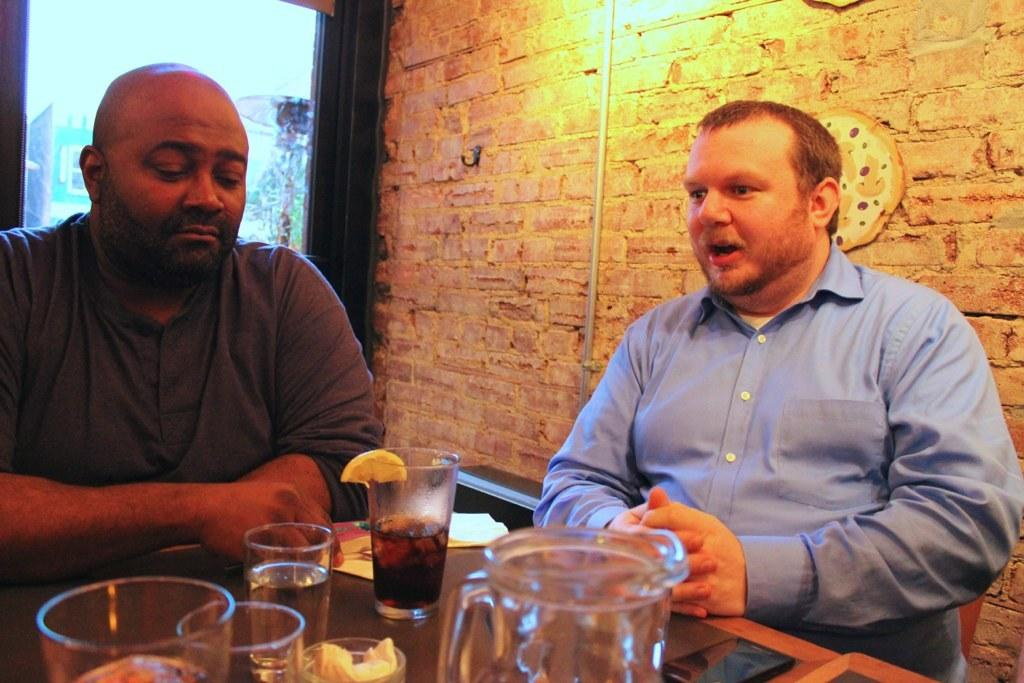What are the people in the image doing? There are persons sitting at the table in the image. What objects can be seen on the table? There are glasses, a beverage, lemons, and a mobile phone on the table. What is visible in the background of the image? There is a wall and a window in the background of the image. What type of reaction can be seen from the girls in the image? There are no girls present in the image, only persons sitting at the table. What is the hydrant's role in the image? There is no hydrant present in the image. 